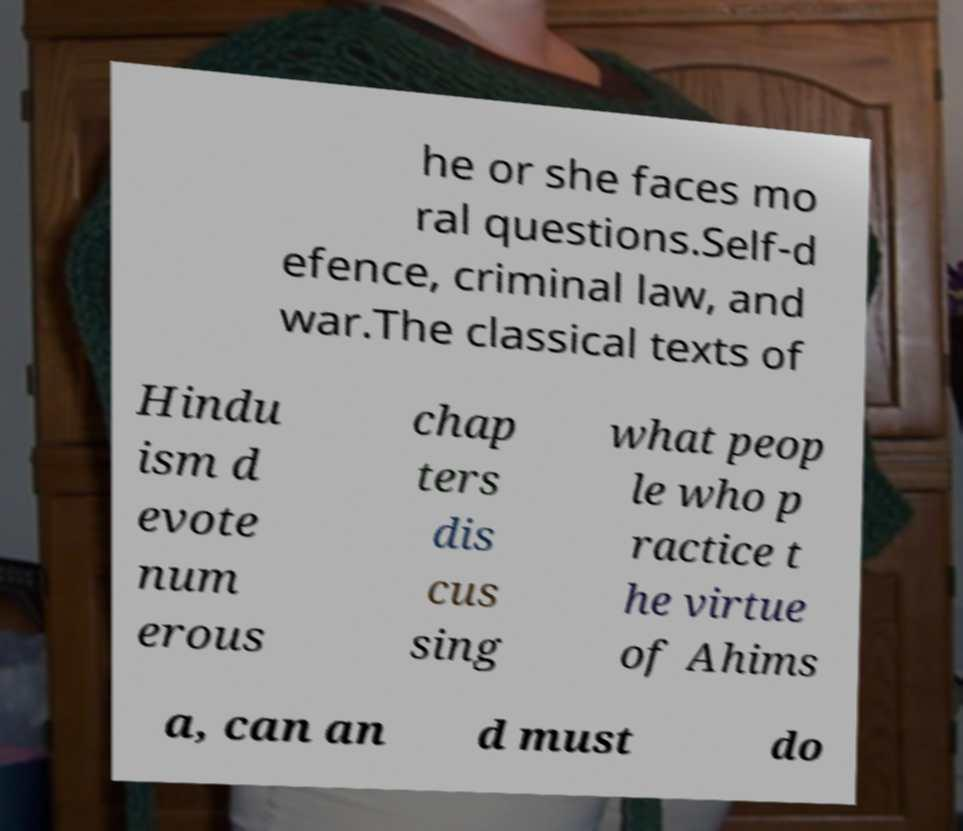Can you accurately transcribe the text from the provided image for me? he or she faces mo ral questions.Self-d efence, criminal law, and war.The classical texts of Hindu ism d evote num erous chap ters dis cus sing what peop le who p ractice t he virtue of Ahims a, can an d must do 